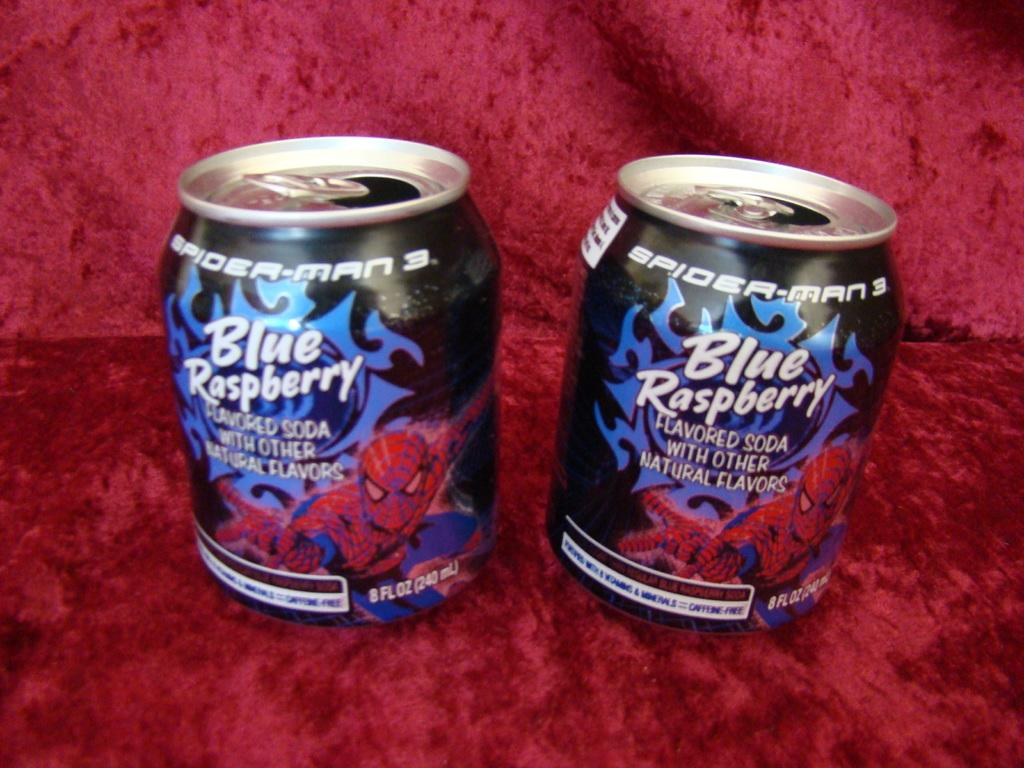<image>
Give a short and clear explanation of the subsequent image. two cans with spider man picture and Blue Raspberry name on it 